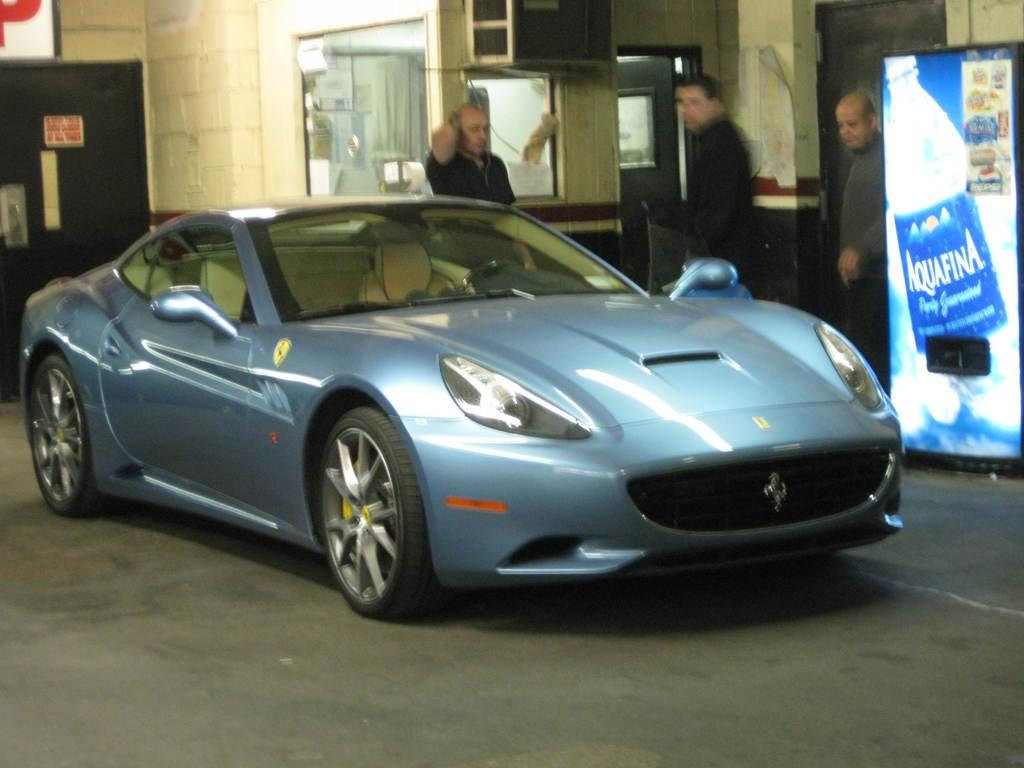What is the main subject of the image? There is a vehicle in the image. Can you describe the people in the image? There are people in the image. What type of structures are visible in the image? There are walls, doors, and windows in the image. What other objects can be seen in the image? There are boards and posters in the image. What type of comfort can be seen in the image? There is no specific comfort item or feature visible in the image. Where is the vacation destination depicted in the image? There is no vacation destination depicted in the image; it features a vehicle, people, and various structures and objects. 